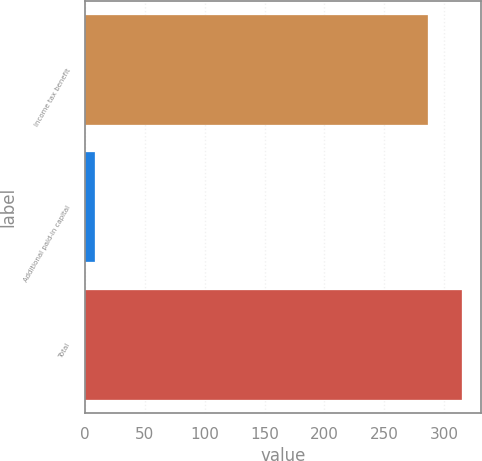<chart> <loc_0><loc_0><loc_500><loc_500><bar_chart><fcel>Income tax benefit<fcel>Additional paid-in capital<fcel>Total<nl><fcel>286<fcel>9<fcel>314.6<nl></chart> 